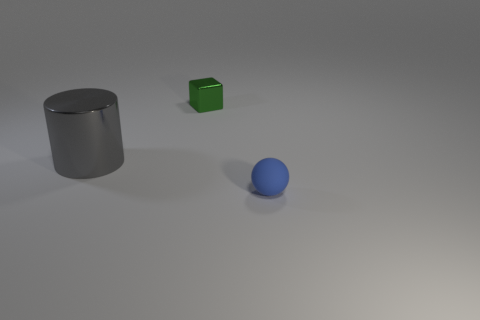Add 1 gray shiny cylinders. How many objects exist? 4 Subtract all cubes. How many objects are left? 2 Add 2 green metal objects. How many green metal objects exist? 3 Subtract 0 gray cubes. How many objects are left? 3 Subtract all matte spheres. Subtract all tiny rubber things. How many objects are left? 1 Add 2 green cubes. How many green cubes are left? 3 